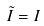Convert formula to latex. <formula><loc_0><loc_0><loc_500><loc_500>\tilde { I } = I</formula> 